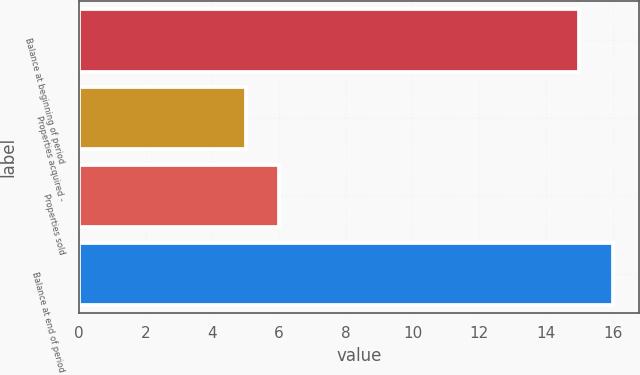<chart> <loc_0><loc_0><loc_500><loc_500><bar_chart><fcel>Balance at beginning of period<fcel>Properties acquired -<fcel>Properties sold<fcel>Balance at end of period<nl><fcel>15<fcel>5<fcel>6<fcel>16<nl></chart> 